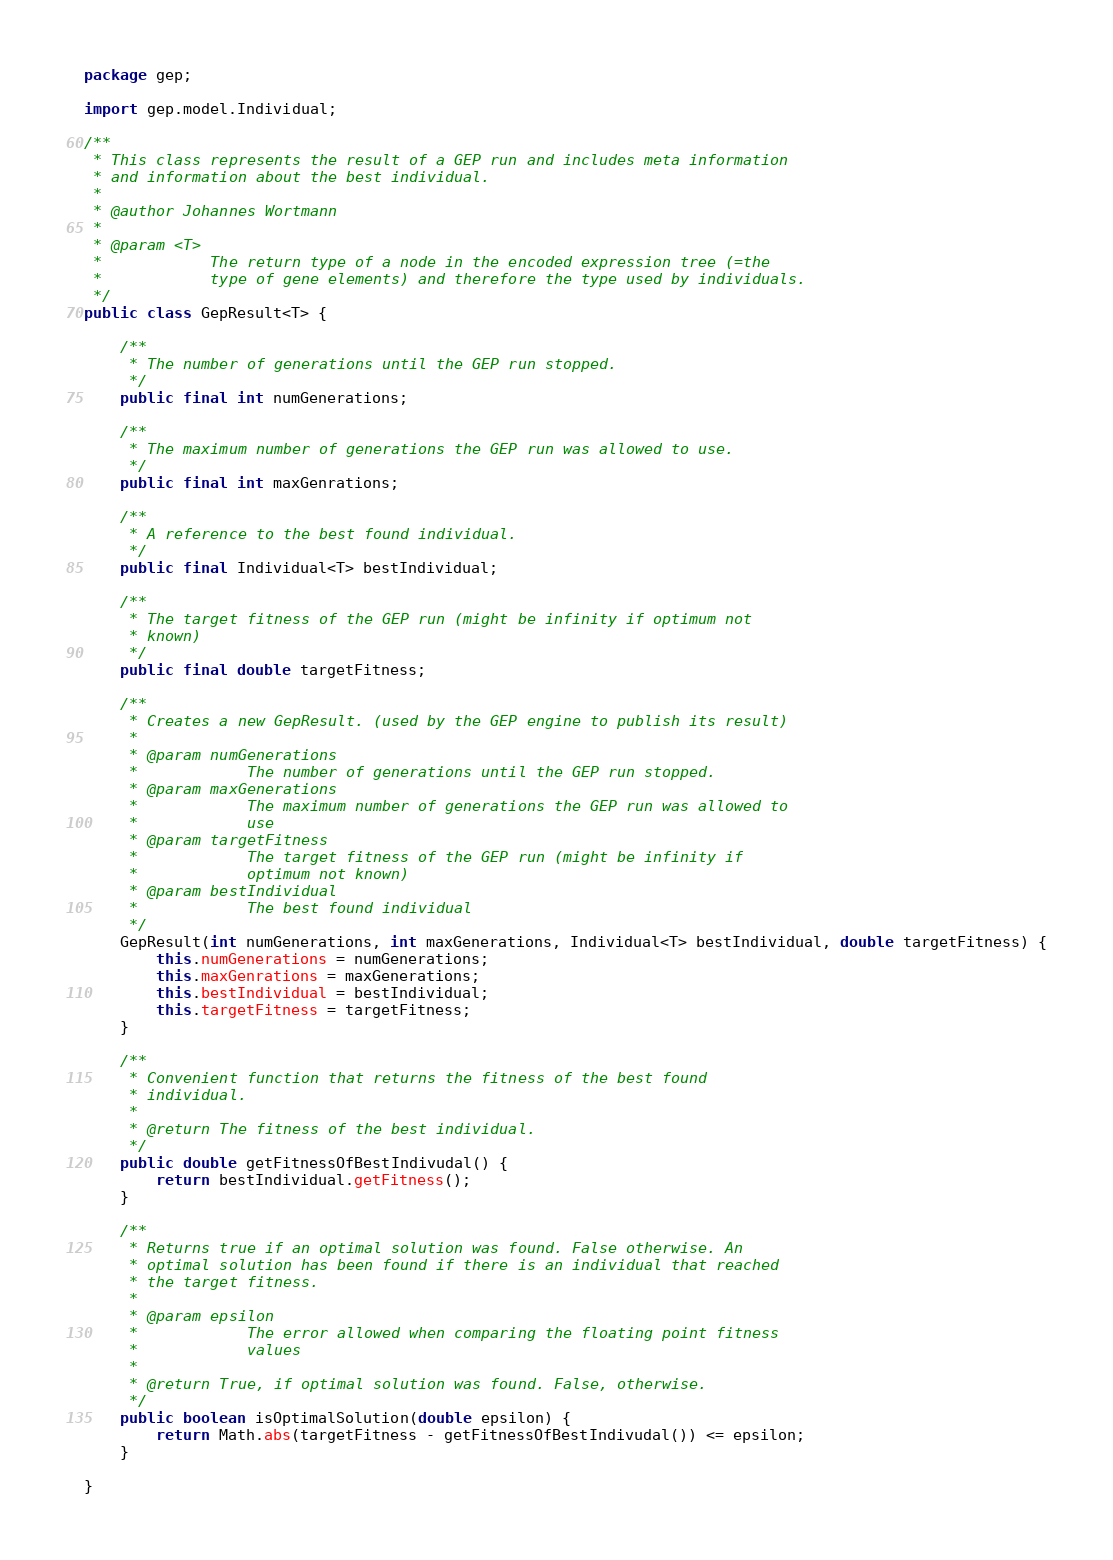Convert code to text. <code><loc_0><loc_0><loc_500><loc_500><_Java_>package gep;

import gep.model.Individual;

/**
 * This class represents the result of a GEP run and includes meta information
 * and information about the best individual.
 * 
 * @author Johannes Wortmann
 *
 * @param <T>
 *            The return type of a node in the encoded expression tree (=the
 *            type of gene elements) and therefore the type used by individuals.
 */
public class GepResult<T> {

	/**
	 * The number of generations until the GEP run stopped.
	 */
	public final int numGenerations;

	/**
	 * The maximum number of generations the GEP run was allowed to use.
	 */
	public final int maxGenrations;

	/**
	 * A reference to the best found individual.
	 */
	public final Individual<T> bestIndividual;

	/**
	 * The target fitness of the GEP run (might be infinity if optimum not
	 * known)
	 */
	public final double targetFitness;

	/**
	 * Creates a new GepResult. (used by the GEP engine to publish its result)
	 * 
	 * @param numGenerations
	 *            The number of generations until the GEP run stopped.
	 * @param maxGenerations
	 *            The maximum number of generations the GEP run was allowed to
	 *            use
	 * @param targetFitness
	 *            The target fitness of the GEP run (might be infinity if
	 *            optimum not known)
	 * @param bestIndividual
	 *            The best found individual
	 */
	GepResult(int numGenerations, int maxGenerations, Individual<T> bestIndividual, double targetFitness) {
		this.numGenerations = numGenerations;
		this.maxGenrations = maxGenerations;
		this.bestIndividual = bestIndividual;
		this.targetFitness = targetFitness;
	}

	/**
	 * Convenient function that returns the fitness of the best found
	 * individual.
	 * 
	 * @return The fitness of the best individual.
	 */
	public double getFitnessOfBestIndivudal() {
		return bestIndividual.getFitness();
	}

	/**
	 * Returns true if an optimal solution was found. False otherwise. An
	 * optimal solution has been found if there is an individual that reached
	 * the target fitness.
	 * 
	 * @param epsilon
	 *            The error allowed when comparing the floating point fitness
	 *            values
	 * 
	 * @return True, if optimal solution was found. False, otherwise.
	 */
	public boolean isOptimalSolution(double epsilon) {
		return Math.abs(targetFitness - getFitnessOfBestIndivudal()) <= epsilon;
	}

}
</code> 